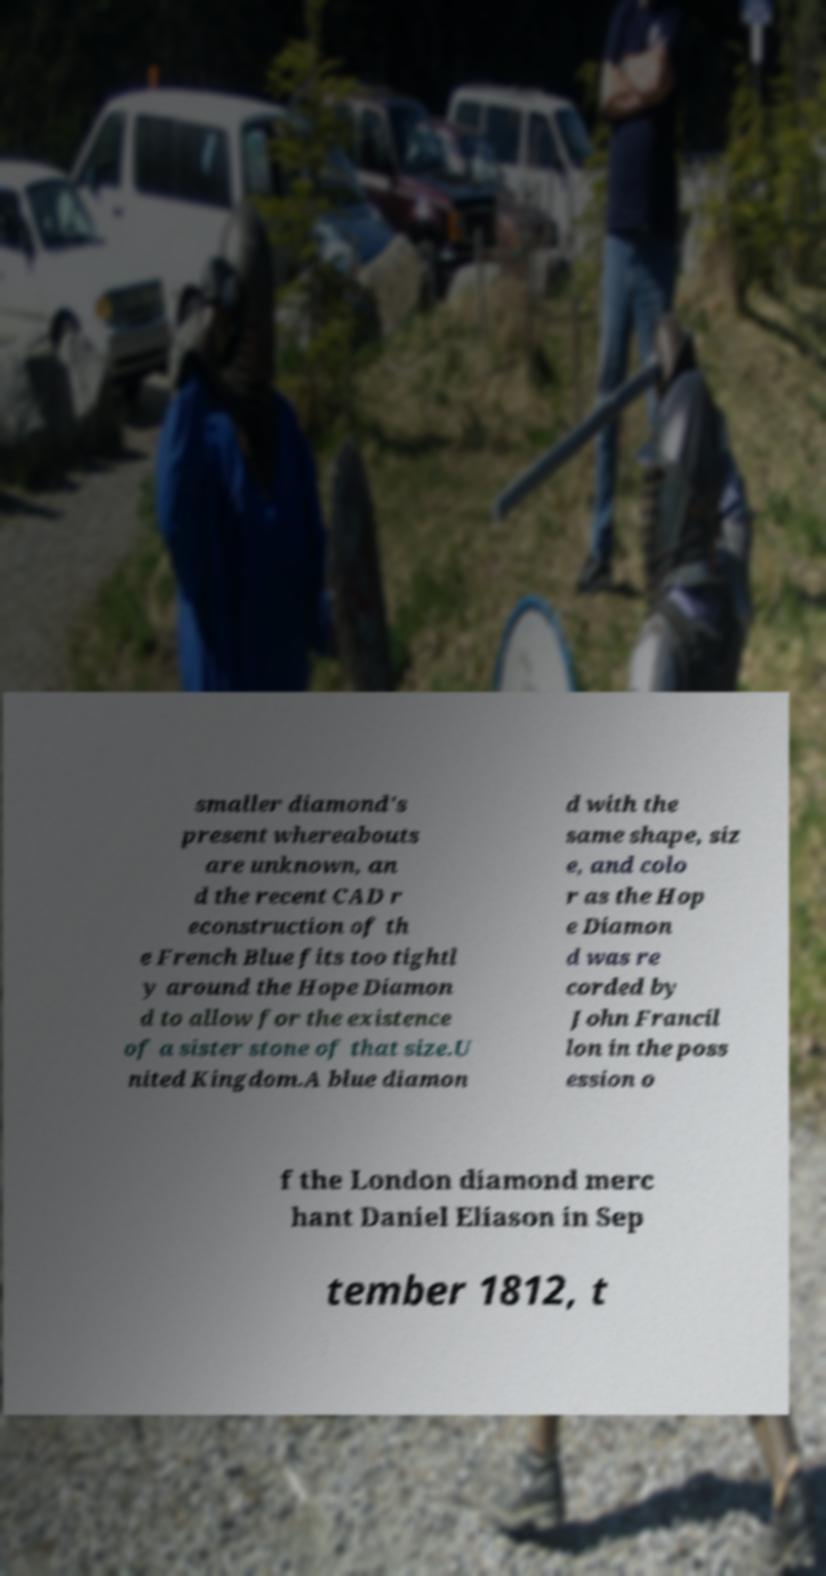I need the written content from this picture converted into text. Can you do that? smaller diamond's present whereabouts are unknown, an d the recent CAD r econstruction of th e French Blue fits too tightl y around the Hope Diamon d to allow for the existence of a sister stone of that size.U nited Kingdom.A blue diamon d with the same shape, siz e, and colo r as the Hop e Diamon d was re corded by John Francil lon in the poss ession o f the London diamond merc hant Daniel Eliason in Sep tember 1812, t 